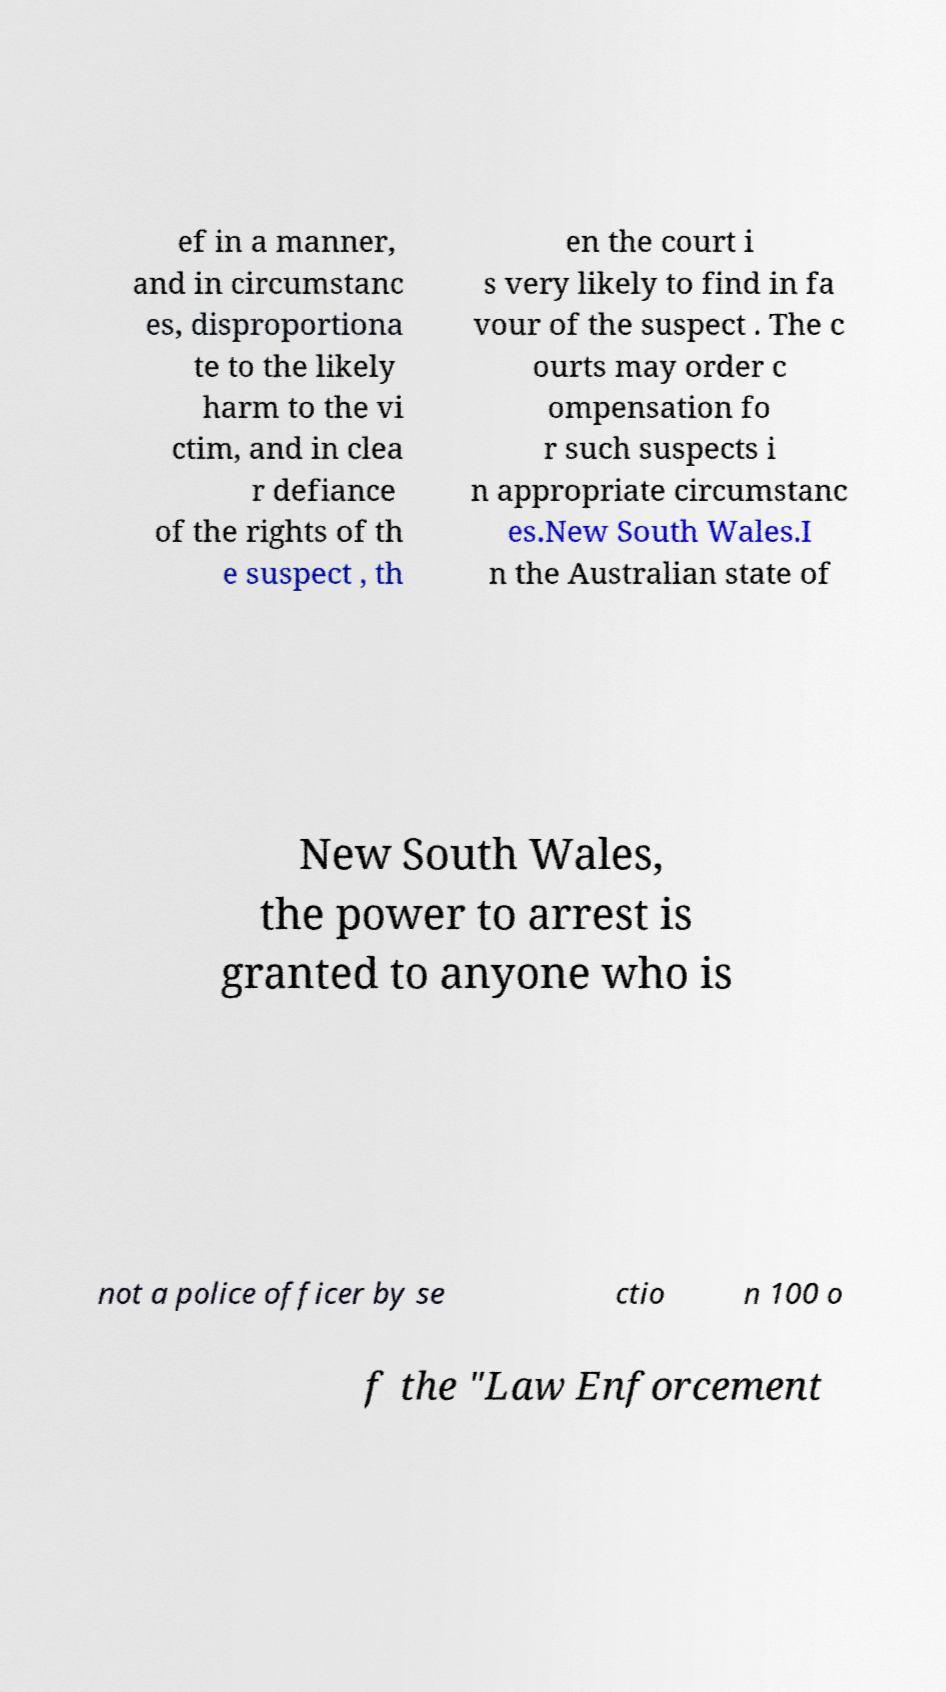Could you extract and type out the text from this image? ef in a manner, and in circumstanc es, disproportiona te to the likely harm to the vi ctim, and in clea r defiance of the rights of th e suspect , th en the court i s very likely to find in fa vour of the suspect . The c ourts may order c ompensation fo r such suspects i n appropriate circumstanc es.New South Wales.I n the Australian state of New South Wales, the power to arrest is granted to anyone who is not a police officer by se ctio n 100 o f the "Law Enforcement 